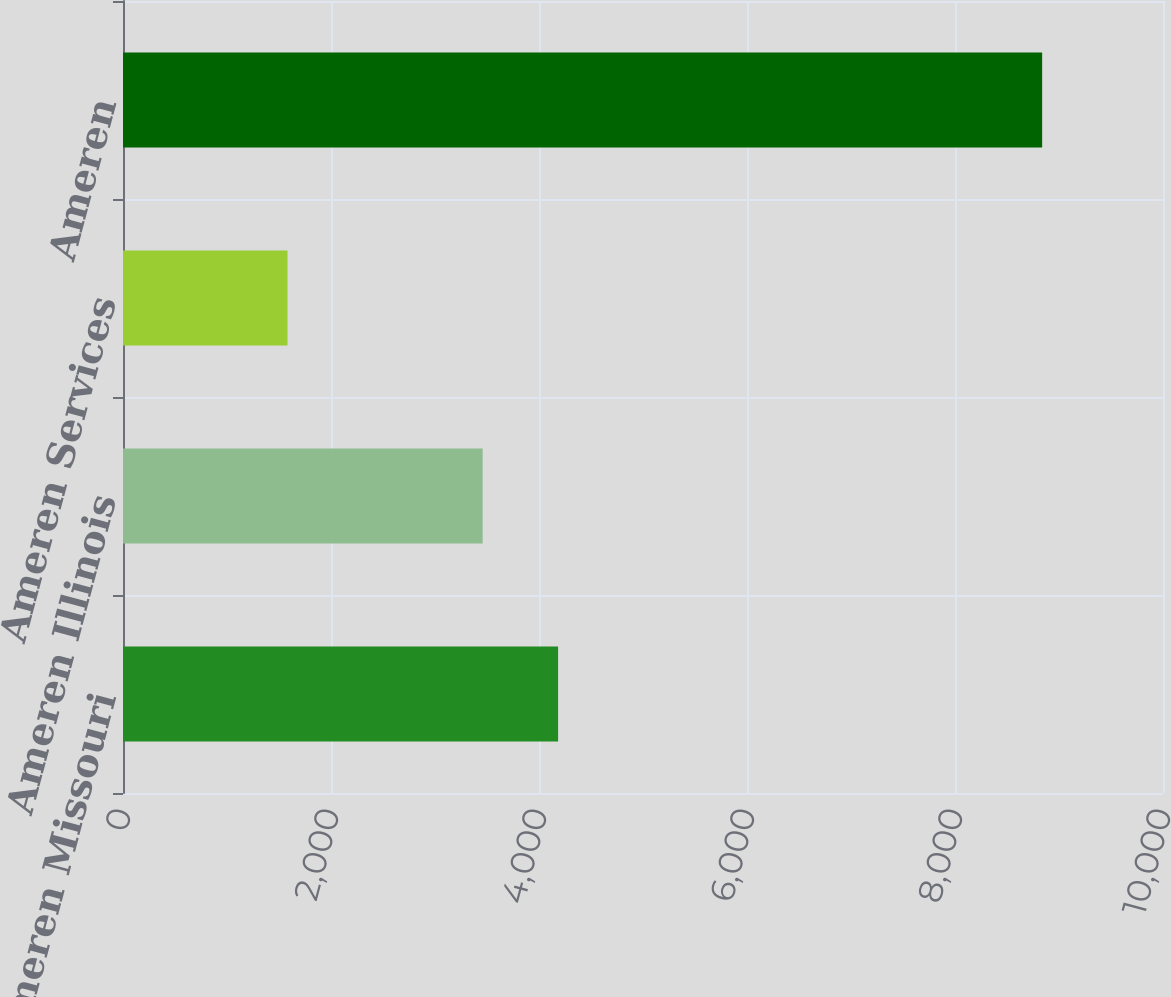<chart> <loc_0><loc_0><loc_500><loc_500><bar_chart><fcel>Ameren Missouri<fcel>Ameren Illinois<fcel>Ameren Services<fcel>Ameren<nl><fcel>4183.6<fcel>3458<fcel>1582<fcel>8838<nl></chart> 